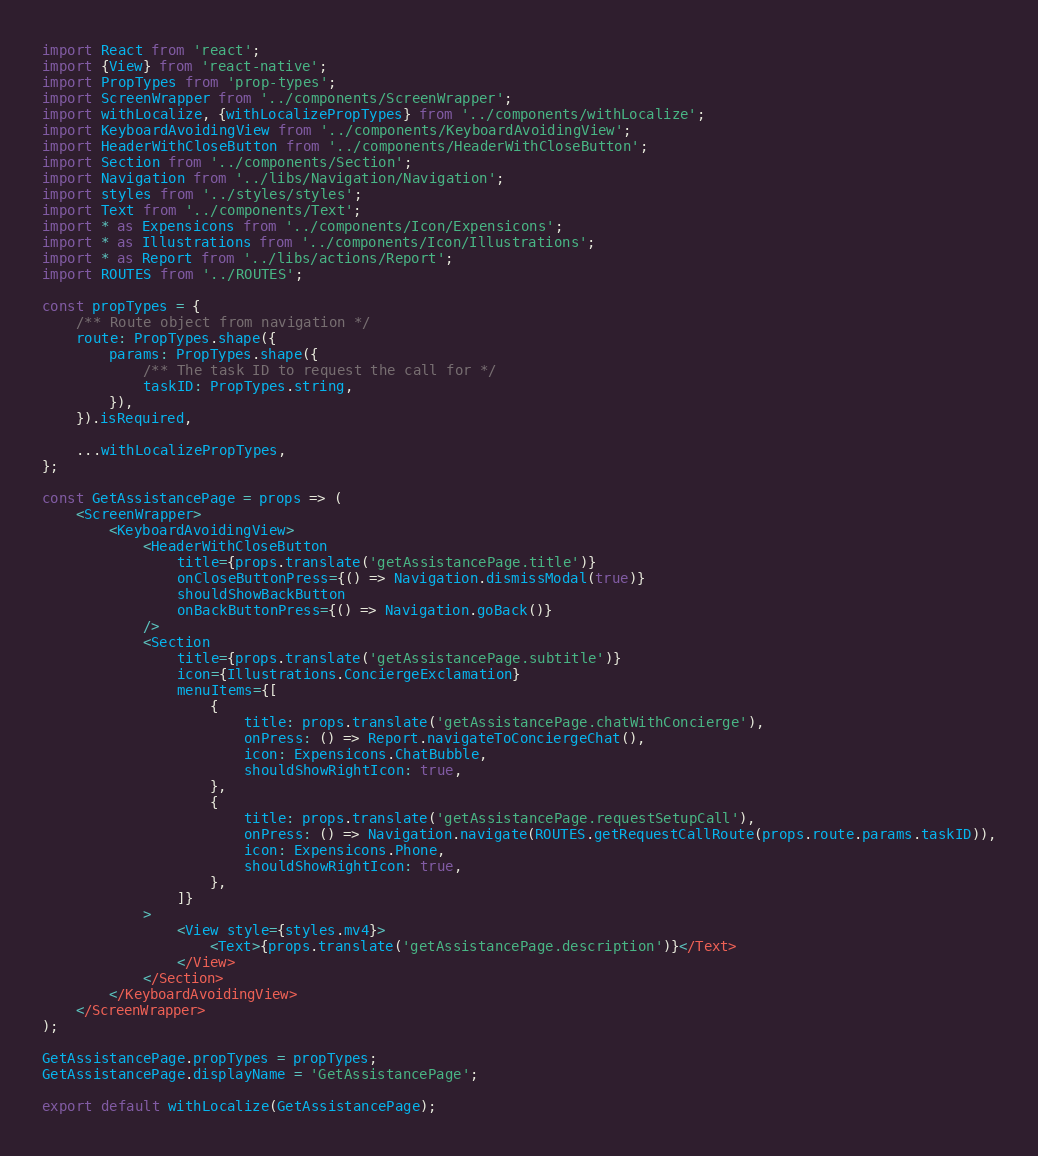<code> <loc_0><loc_0><loc_500><loc_500><_JavaScript_>import React from 'react';
import {View} from 'react-native';
import PropTypes from 'prop-types';
import ScreenWrapper from '../components/ScreenWrapper';
import withLocalize, {withLocalizePropTypes} from '../components/withLocalize';
import KeyboardAvoidingView from '../components/KeyboardAvoidingView';
import HeaderWithCloseButton from '../components/HeaderWithCloseButton';
import Section from '../components/Section';
import Navigation from '../libs/Navigation/Navigation';
import styles from '../styles/styles';
import Text from '../components/Text';
import * as Expensicons from '../components/Icon/Expensicons';
import * as Illustrations from '../components/Icon/Illustrations';
import * as Report from '../libs/actions/Report';
import ROUTES from '../ROUTES';

const propTypes = {
    /** Route object from navigation */
    route: PropTypes.shape({
        params: PropTypes.shape({
            /** The task ID to request the call for */
            taskID: PropTypes.string,
        }),
    }).isRequired,

    ...withLocalizePropTypes,
};

const GetAssistancePage = props => (
    <ScreenWrapper>
        <KeyboardAvoidingView>
            <HeaderWithCloseButton
                title={props.translate('getAssistancePage.title')}
                onCloseButtonPress={() => Navigation.dismissModal(true)}
                shouldShowBackButton
                onBackButtonPress={() => Navigation.goBack()}
            />
            <Section
                title={props.translate('getAssistancePage.subtitle')}
                icon={Illustrations.ConciergeExclamation}
                menuItems={[
                    {
                        title: props.translate('getAssistancePage.chatWithConcierge'),
                        onPress: () => Report.navigateToConciergeChat(),
                        icon: Expensicons.ChatBubble,
                        shouldShowRightIcon: true,
                    },
                    {
                        title: props.translate('getAssistancePage.requestSetupCall'),
                        onPress: () => Navigation.navigate(ROUTES.getRequestCallRoute(props.route.params.taskID)),
                        icon: Expensicons.Phone,
                        shouldShowRightIcon: true,
                    },
                ]}
            >
                <View style={styles.mv4}>
                    <Text>{props.translate('getAssistancePage.description')}</Text>
                </View>
            </Section>
        </KeyboardAvoidingView>
    </ScreenWrapper>
);

GetAssistancePage.propTypes = propTypes;
GetAssistancePage.displayName = 'GetAssistancePage';

export default withLocalize(GetAssistancePage);
</code> 